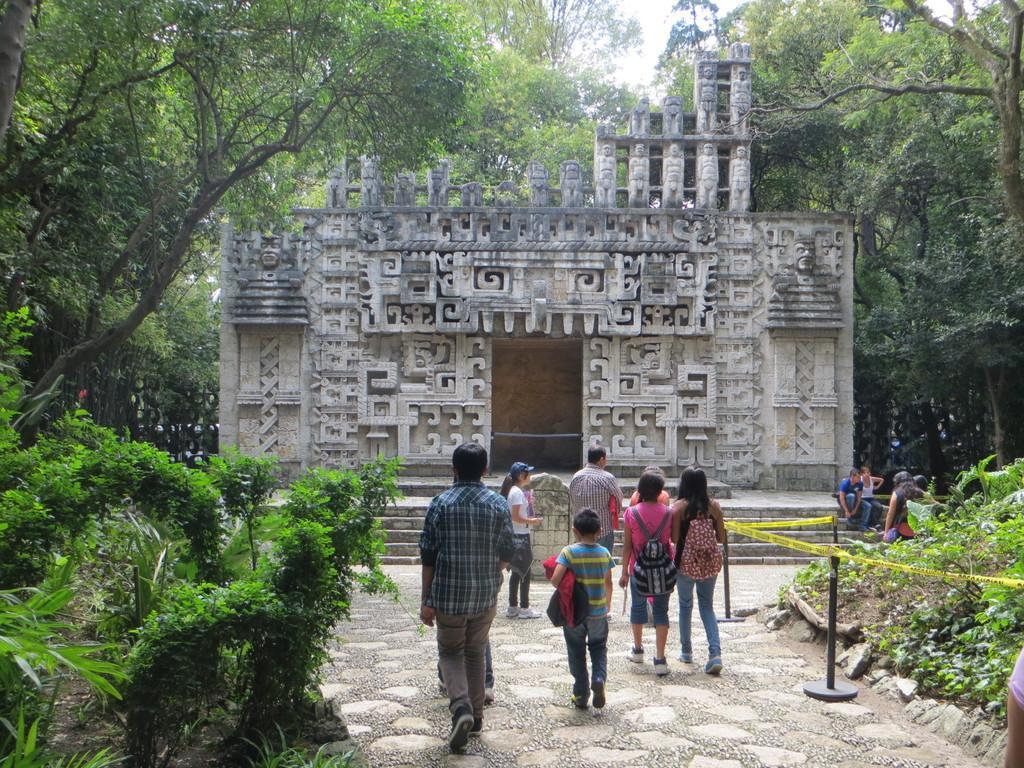In one or two sentences, can you explain what this image depicts? In this picture we can see a man who is wearing shirt, trouser and shoe. Beside him there is another boy who is wearing jacket. Here we can see the group of women standing near to the fencing. In the background we can see monument. On the left we can see grass and plants. At the top there is a sky. 